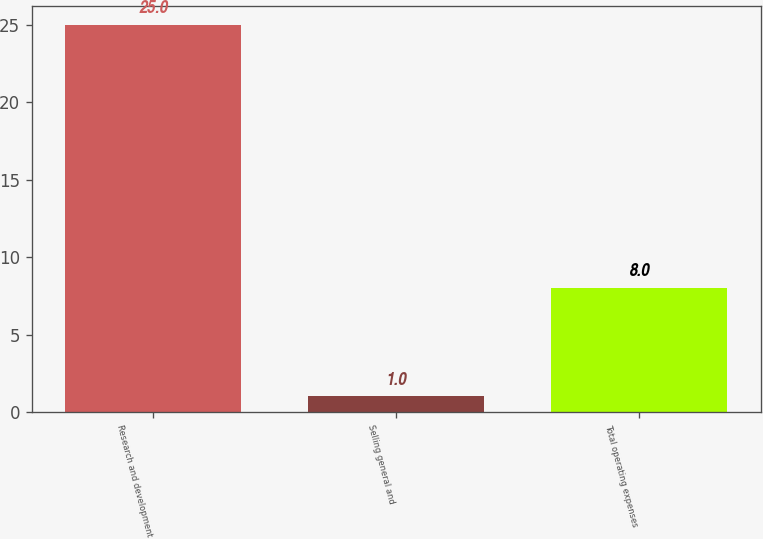Convert chart. <chart><loc_0><loc_0><loc_500><loc_500><bar_chart><fcel>Research and development<fcel>Selling general and<fcel>Total operating expenses<nl><fcel>25<fcel>1<fcel>8<nl></chart> 